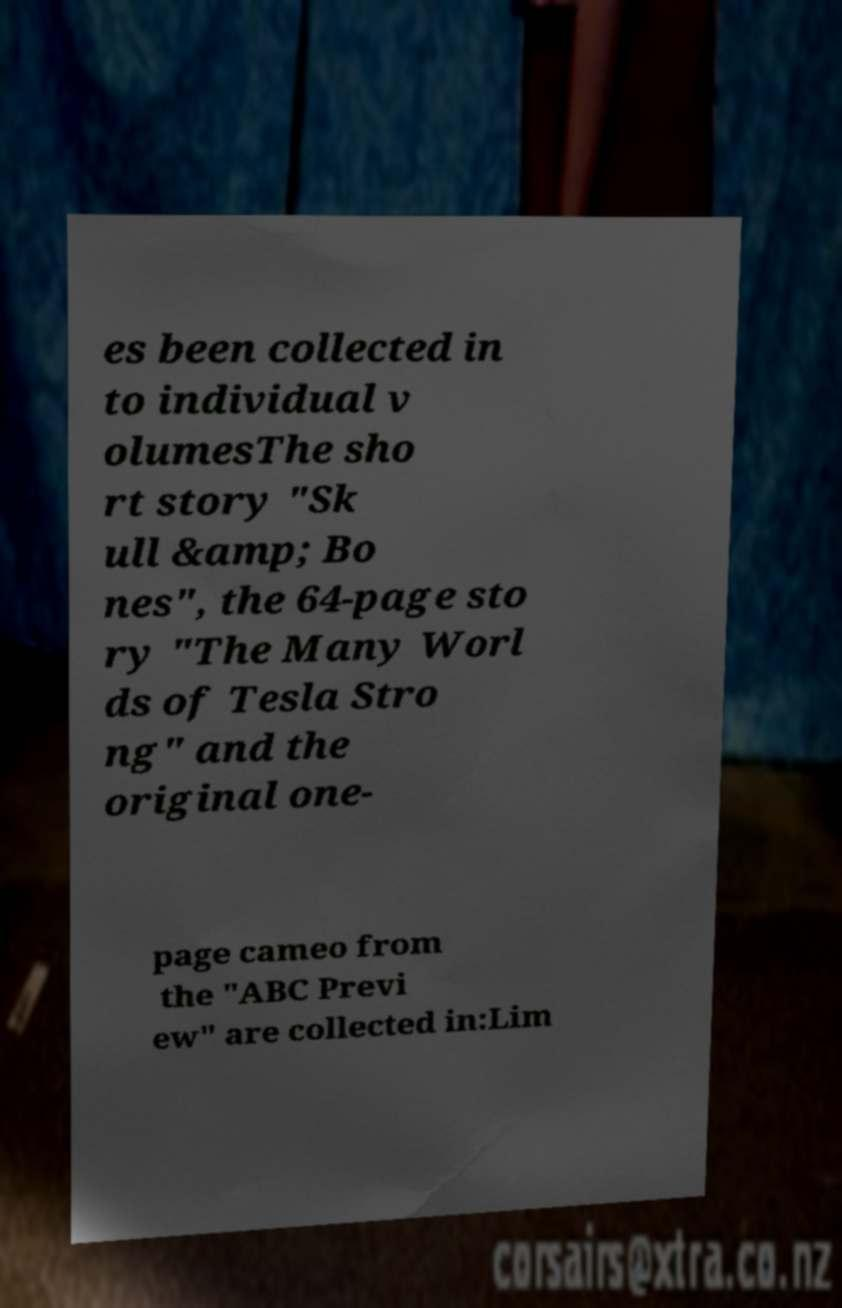Can you read and provide the text displayed in the image?This photo seems to have some interesting text. Can you extract and type it out for me? es been collected in to individual v olumesThe sho rt story "Sk ull &amp; Bo nes", the 64-page sto ry "The Many Worl ds of Tesla Stro ng" and the original one- page cameo from the "ABC Previ ew" are collected in:Lim 